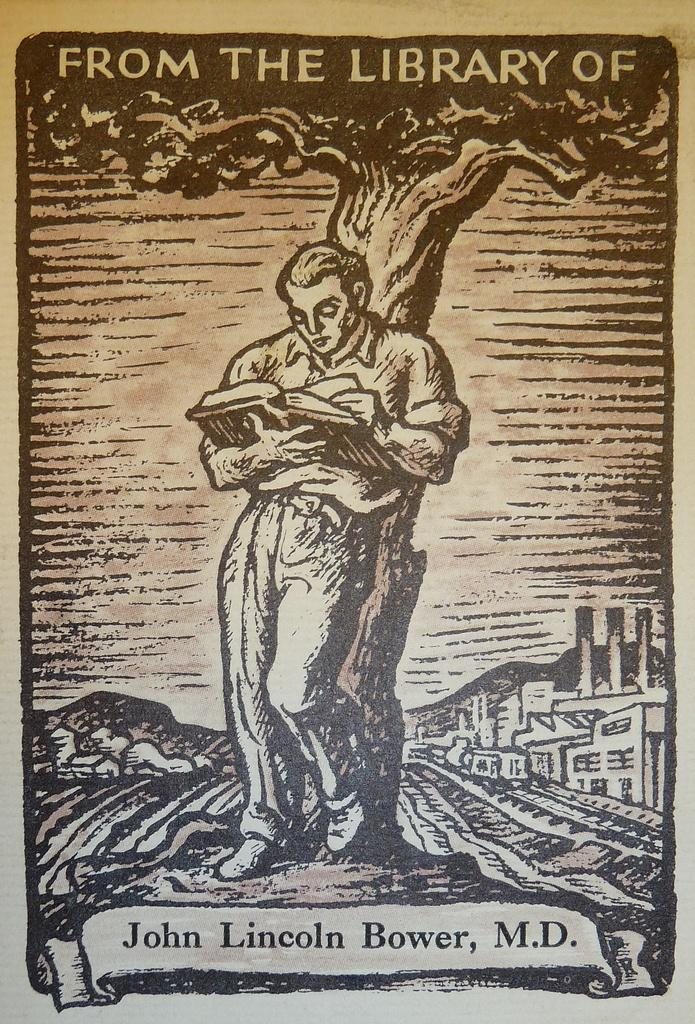What is featured on the poster in the image? Unfortunately, the provided facts do not specify what is on the poster. However, we can describe the poster as being present in the image. What is the man in the image doing? The man in the image is standing and holding a book in his hand. What can be seen in the background of the image? There is a tree visible in the image. What type of horn is the man playing in the image? There is no horn present in the image; the man is holding a book in his hand. 